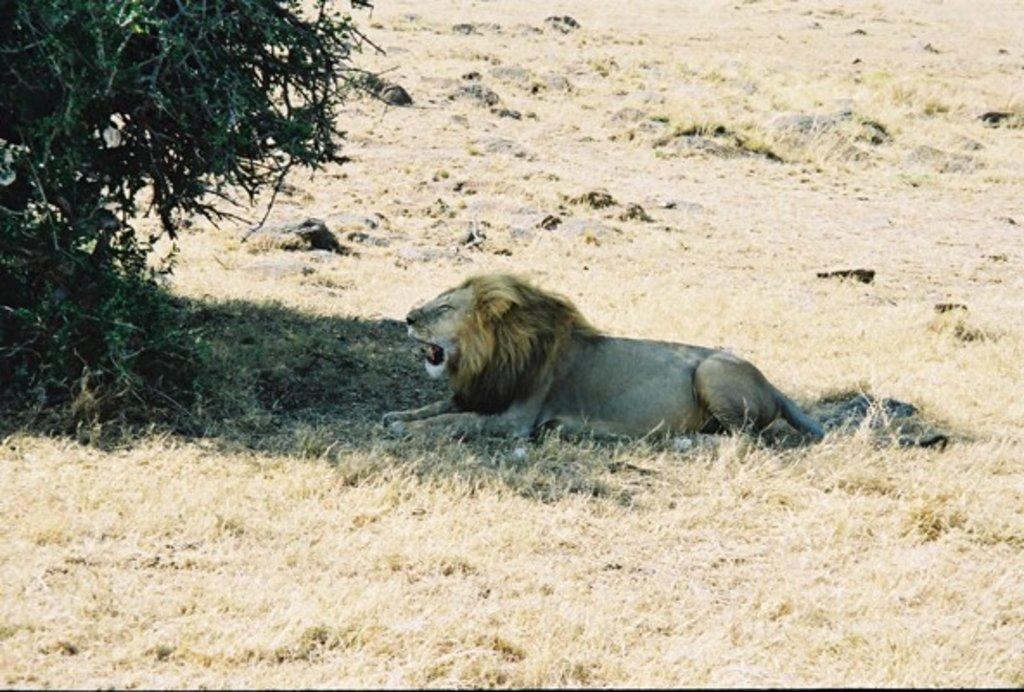What animal is sitting on the ground in the image? There is a lion sitting on the ground in the image. What type of terrain is visible in the image? There is grass and rocks on the ground in the image. What can be seen on the left side of the image? There is a tree on the left side of the image. What is the lion writing in the image? The lion is not writing anything in the image, as lions do not have the ability to write. 